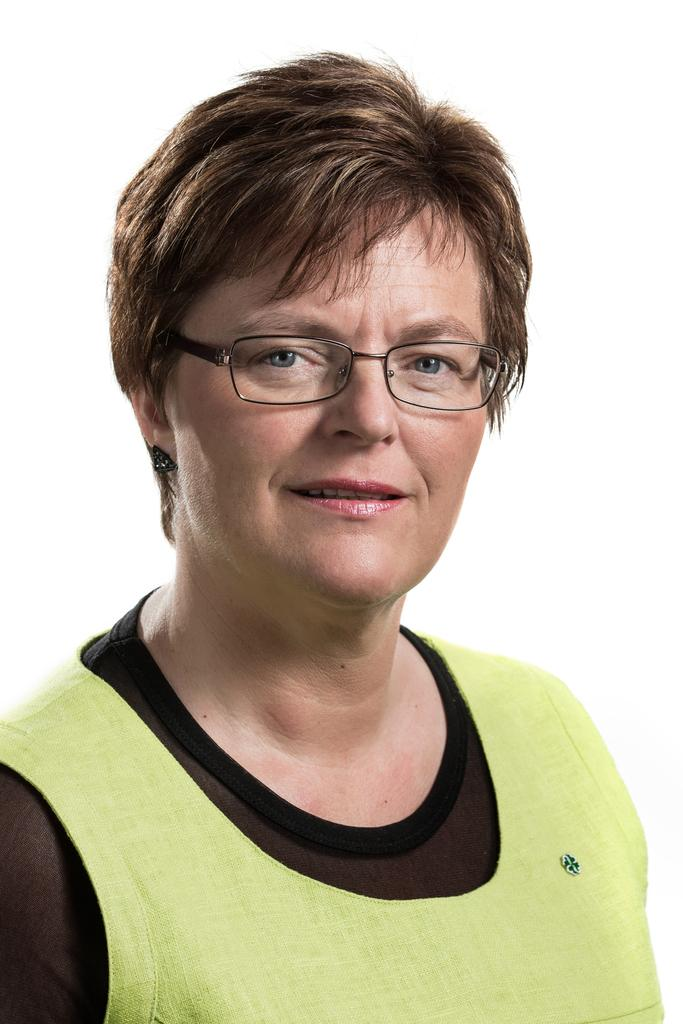What is the main subject of the image? There is a person in the image. What news story does the person in the image tend to follow? There is no information provided about the person's news preferences or any news stories in the image. 